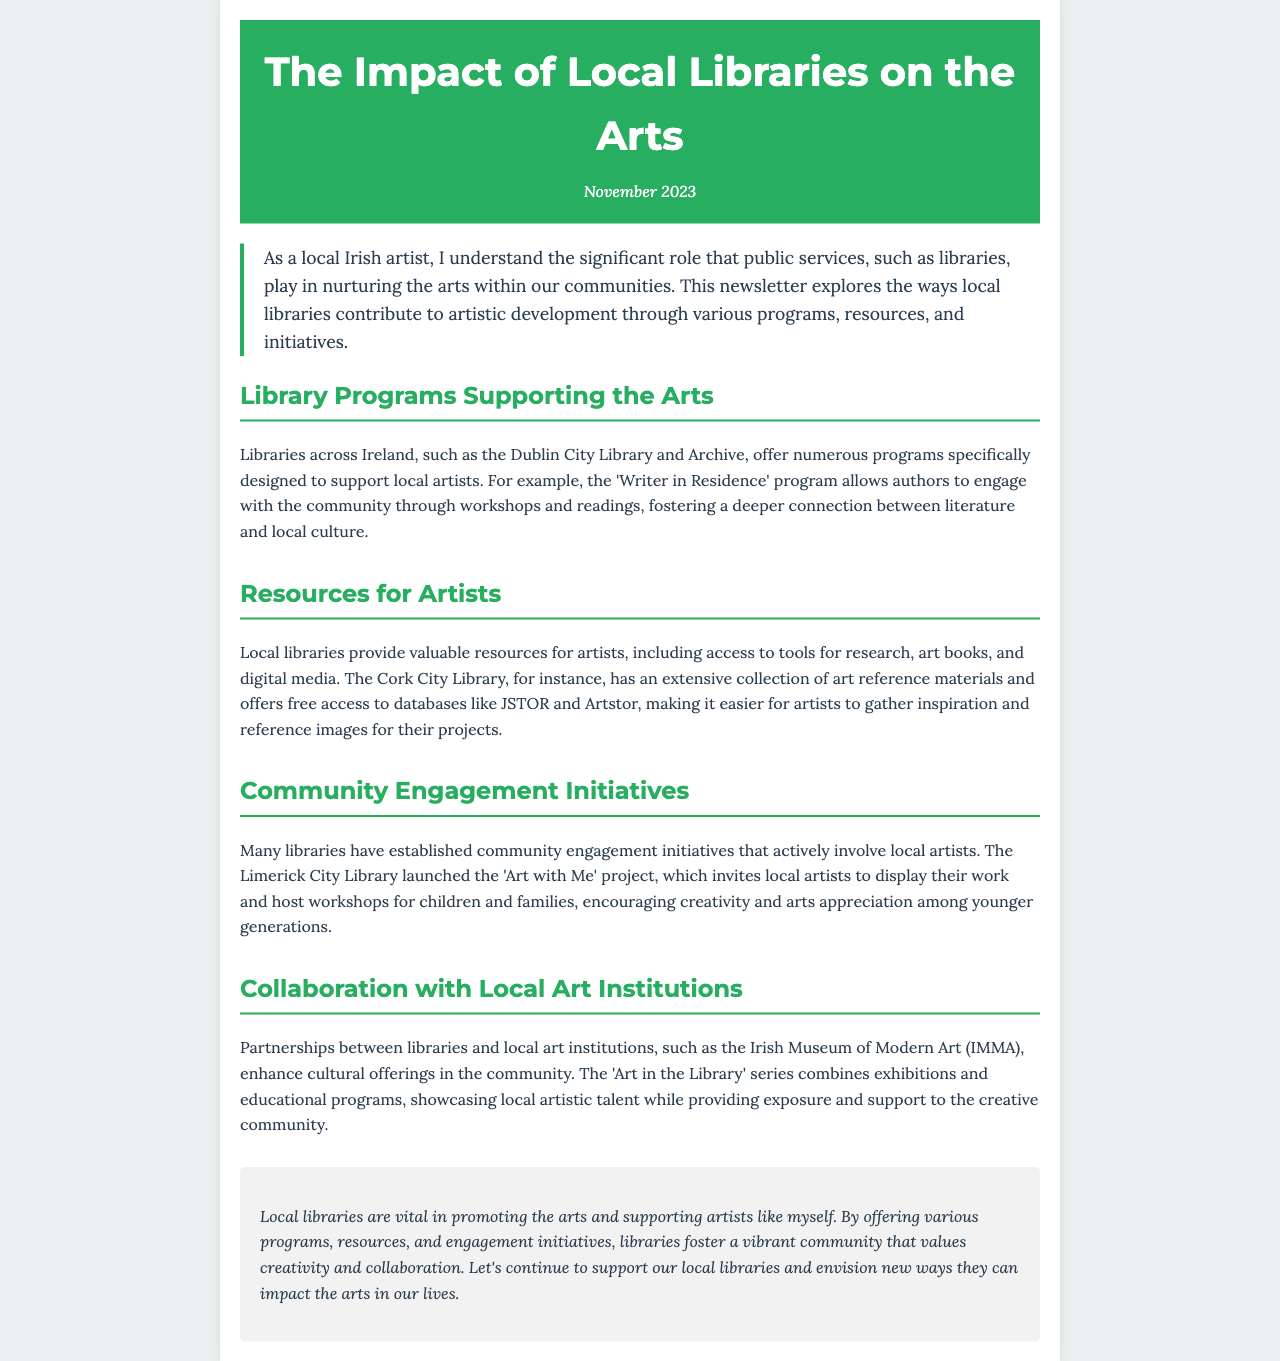What is the title of the newsletter? The title is stated prominently at the top of the document as "The Impact of Local Libraries on the Arts."
Answer: The Impact of Local Libraries on the Arts Which library offers the 'Writer in Residence' program? The document mentions the Dublin City Library and Archive as offering this program.
Answer: Dublin City Library and Archive What initiative invites local artists to display their work? The document specifies the 'Art with Me' project as inviting local artists to display their work.
Answer: Art with Me How many types of library programs are discussed in the document? The document discusses four types of programs: Library Programs, Resources for Artists, Community Engagement Initiatives, and Collaboration with Local Art Institutions.
Answer: Four Name one database available at Cork City Library for artists. The document lists JSTOR as one database available for free access at Cork City Library.
Answer: JSTOR What is one outcome of partnerships between libraries and local art institutions? The document notes that these partnerships enhance cultural offerings in the community.
Answer: Enhance cultural offerings In which month was the newsletter published? The publication date is mentioned in the header of the document as November 2023.
Answer: November 2023 What is the main goal of community engagement initiatives mentioned? The document states that the initiatives aim to encourage creativity and arts appreciation among younger generations.
Answer: Encourage creativity and arts appreciation What is the concluding sentiment expressed about local libraries? The conclusion emphasizes the vital role of libraries in promoting the arts and supporting artists.
Answer: Vital role in promoting the arts 